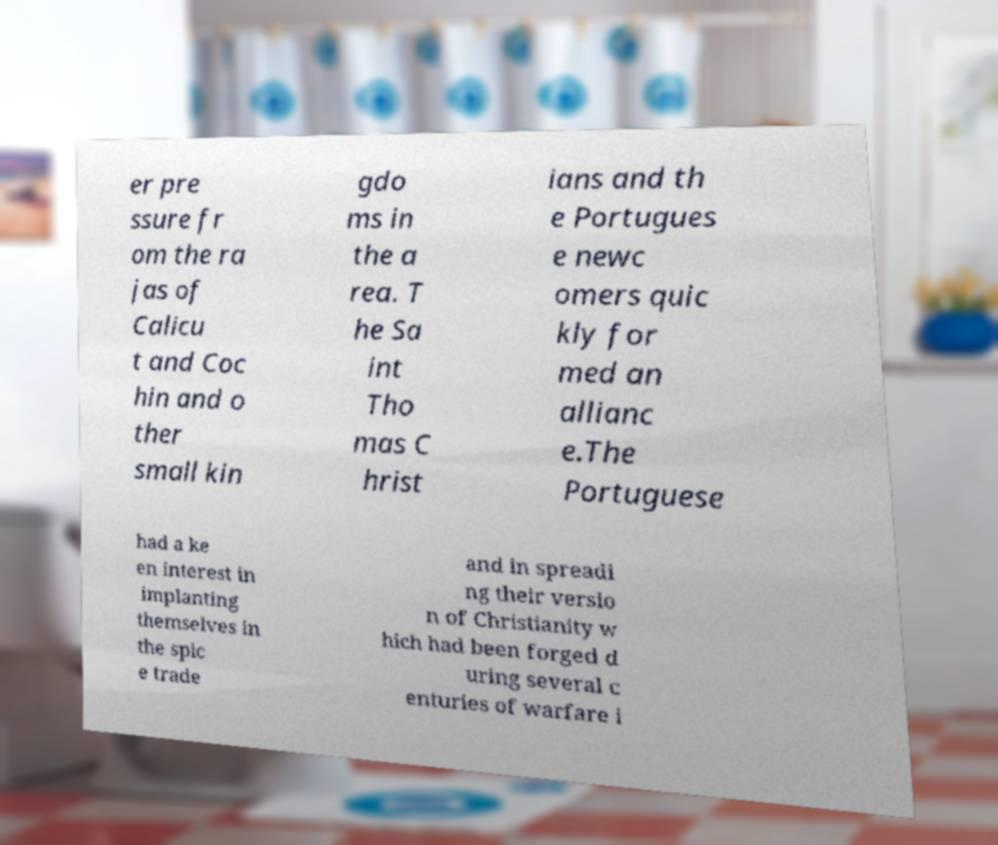Can you read and provide the text displayed in the image?This photo seems to have some interesting text. Can you extract and type it out for me? er pre ssure fr om the ra jas of Calicu t and Coc hin and o ther small kin gdo ms in the a rea. T he Sa int Tho mas C hrist ians and th e Portugues e newc omers quic kly for med an allianc e.The Portuguese had a ke en interest in implanting themselves in the spic e trade and in spreadi ng their versio n of Christianity w hich had been forged d uring several c enturies of warfare i 